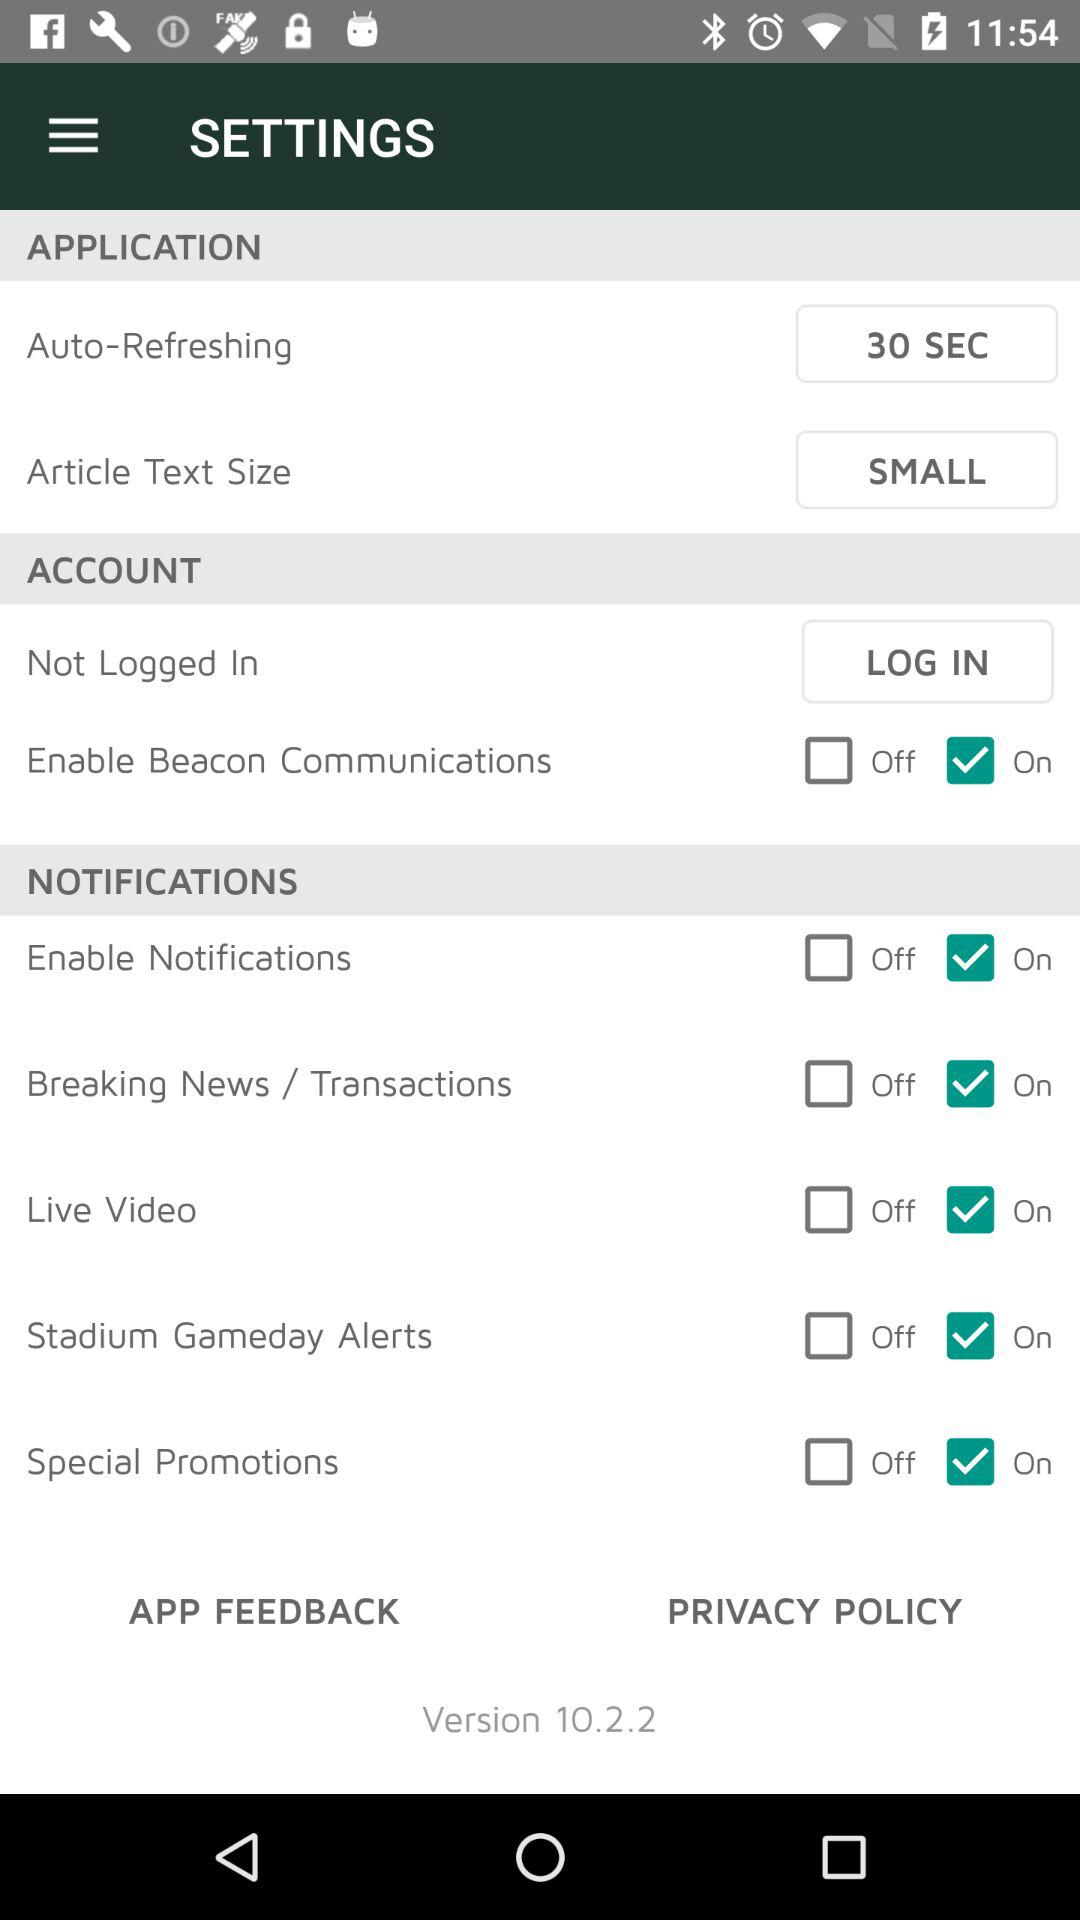After how many seconds does auto-refreshing happen? Auto-refreshing happens after 30 seconds. 